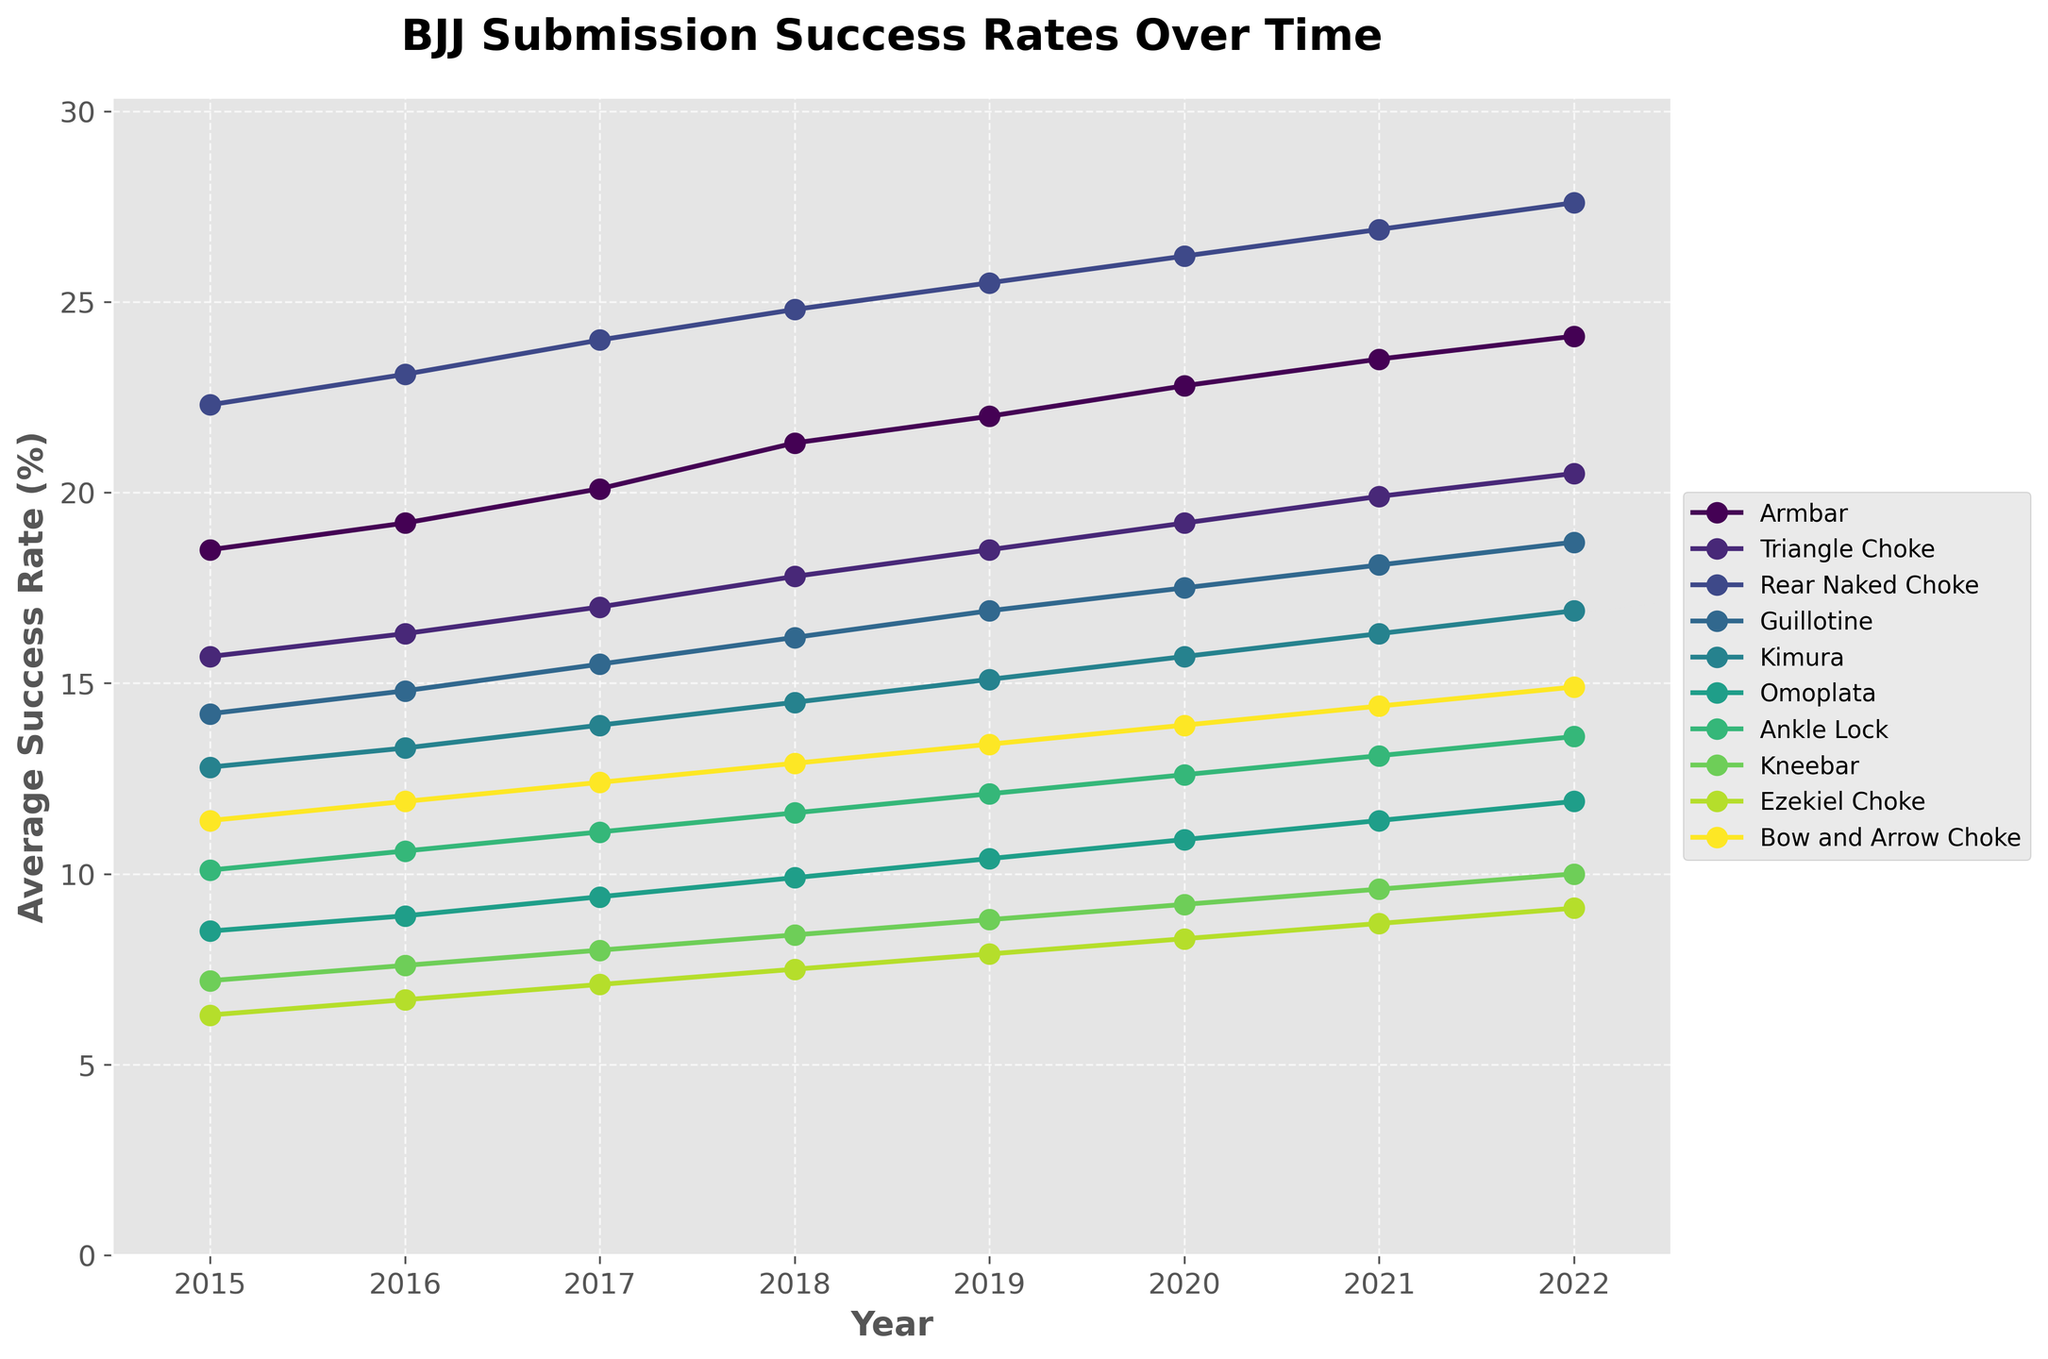Which technique had the highest average success rate in 2022? By looking at the the rates for each technique in 2022, Rear Naked Choke has the highest value at 27.6%.
Answer: Rear Naked Choke How did the success rate of the Armbar change from 2015 to 2022? Subtract the 2015 value (18.5%) from the 2022 value (24.1%). The difference is 5.6% (24.1% - 18.5%).
Answer: Increased by 5.6% Which technique showed the greatest improvement in success rate over the period from 2015 to 2022? Calculate the difference for each technique between 2022 and 2015. The technique with the largest difference is the Rear Naked Choke (27.6% - 22.3% = 5.3%).
Answer: Rear Naked Choke What is the difference in success rate between the Guillotine and the Omoplata in 2020? Subtract the 2020 Omoplata value (10.9%) from the 2020 Guillotine value (17.5%). The difference is 6.6% (17.5% - 10.9%).
Answer: 6.6% On average, how much did the success rate for Kimura increase each year from 2015 to 2022? The total increase from 2015 to 2022 is (16.9% - 12.8% = 4.1%). Divide this by the number of years (7). The average annual increase is 4.1% / 7 ≈ 0.585%.
Answer: 0.585% Were there any years where the success rate of the Triangle Choke was greater than that of the Armbar? No year in which the success rate of the Triangle Choke is higher than the Armbar, as per the visual inspection.
Answer: No Which two techniques had the closest success rates in 2019? Look for techniques with small differences in 2019 values. The Guillotine (16.9%) and Bow and Arrow Choke (13.4%) are the closest, with a difference of (16.9% - 13.4% = 3.5%).
Answer: Guillotine and Bow and Arrow Choke Which technique with a success rate below 15% in 2015 had the greatest increase by 2022? Identify the techniques below 15% in 2015 (Guillotine, Kimura, Omoplata, Ankle Lock, Kneebar, Ezekiel Choke). Calculate each increase from 2015 to 2022. The one with the greatest increase is the Ezekiel Choke (9.1% - 6.3% = 2.8%).
Answer: Ezekiel Choke How many techniques had a success rate above 20% in 2022? Count the techniques with a value above 20% in 2022. They are Armbar, Triangle Choke, and Rear Naked Choke.
Answer: 3 Which technique had the steepest decline or the smallest improvement in success rate between 2015 and 2022? All techniques showed improvement. The one with the smallest improvement is the Ezekiel Choke (9.1% - 6.3% = 2.8%).
Answer: Ezekiel Choke 